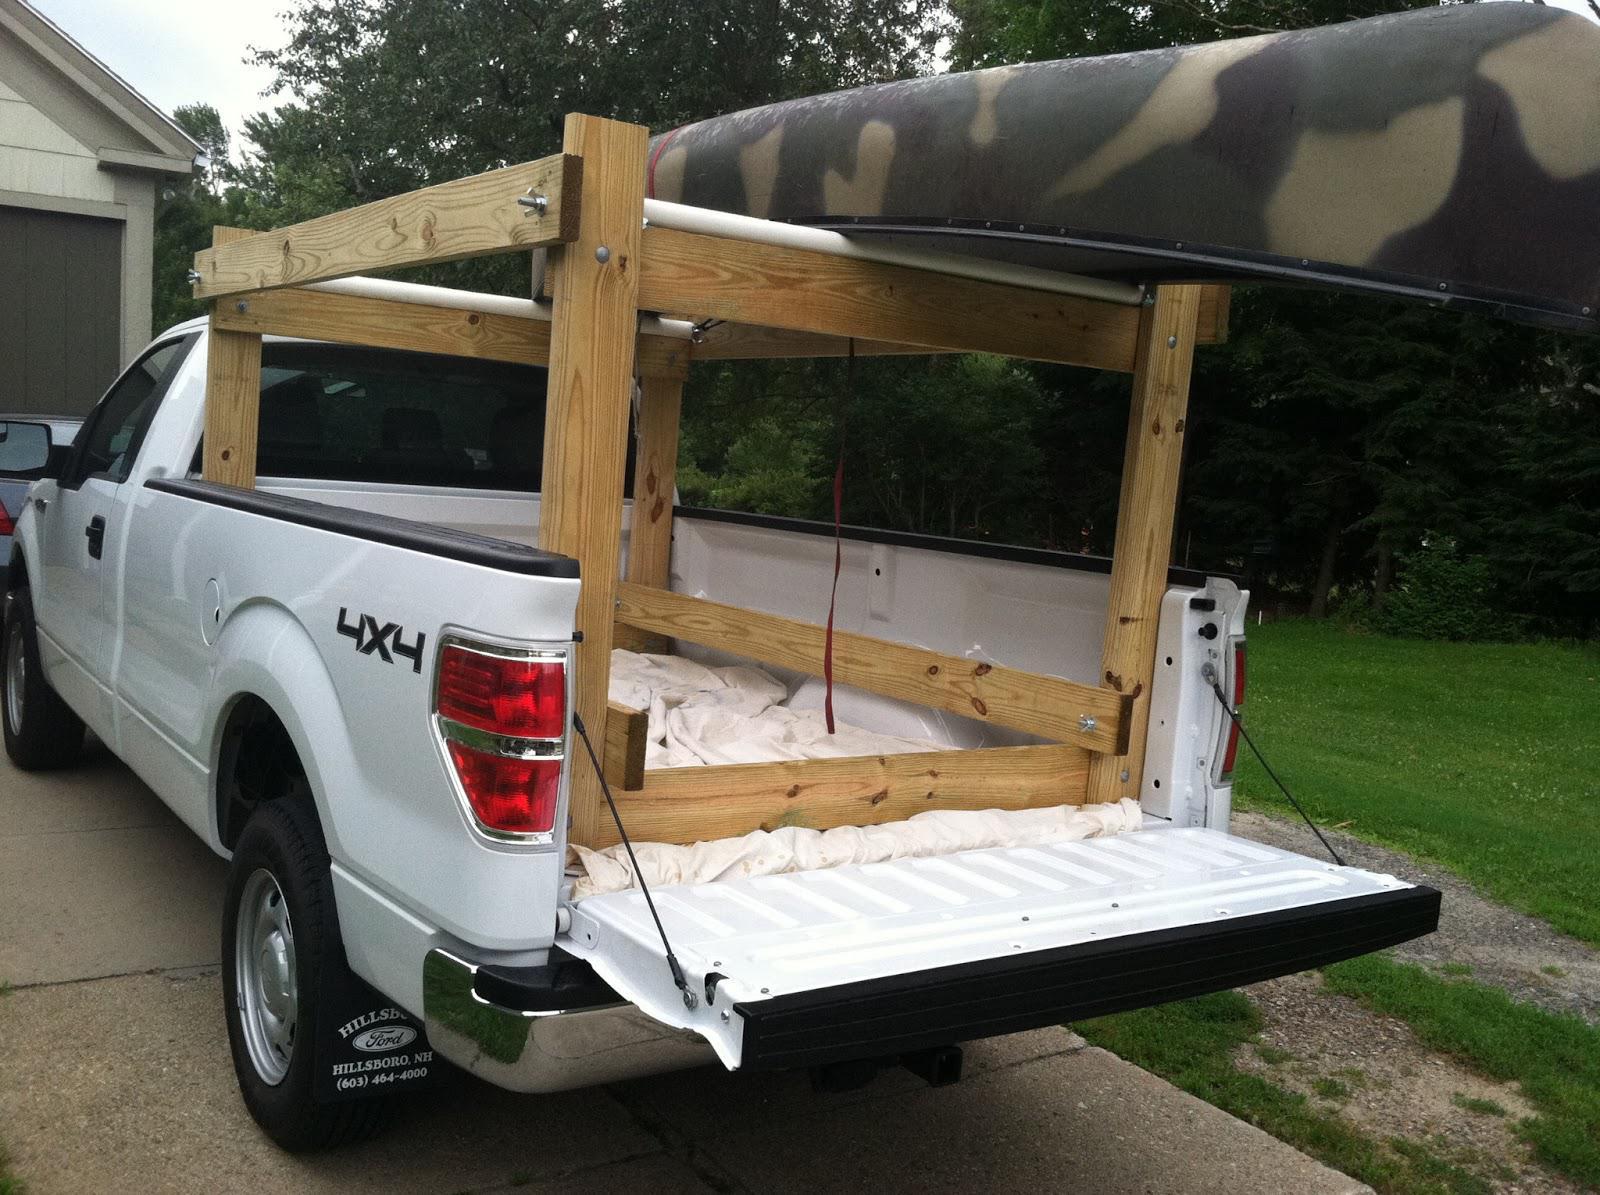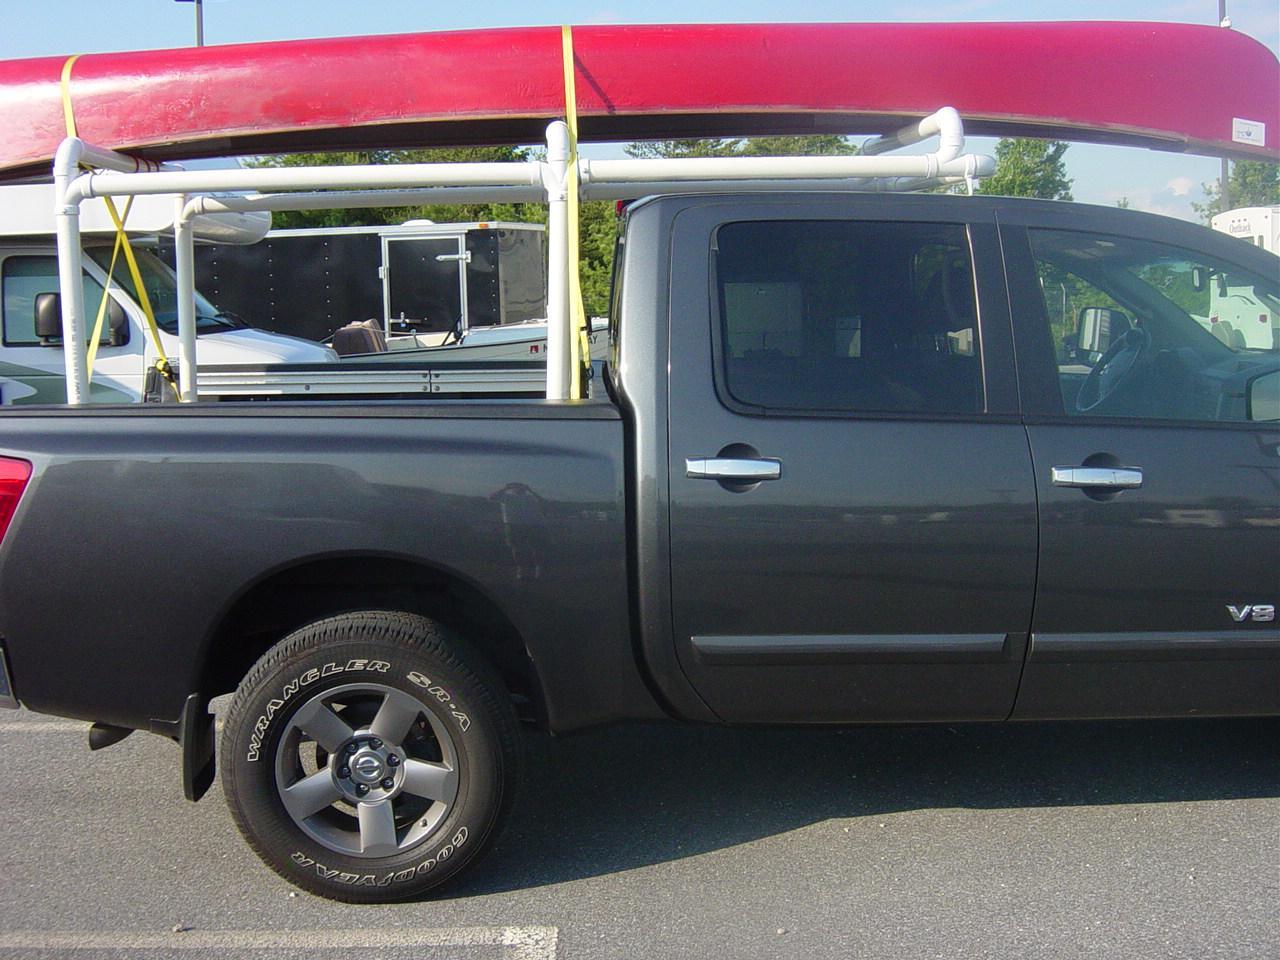The first image is the image on the left, the second image is the image on the right. Examine the images to the left and right. Is the description "A pickup carrying two different colored canoes is heading away from the camera, in one image." accurate? Answer yes or no. No. 